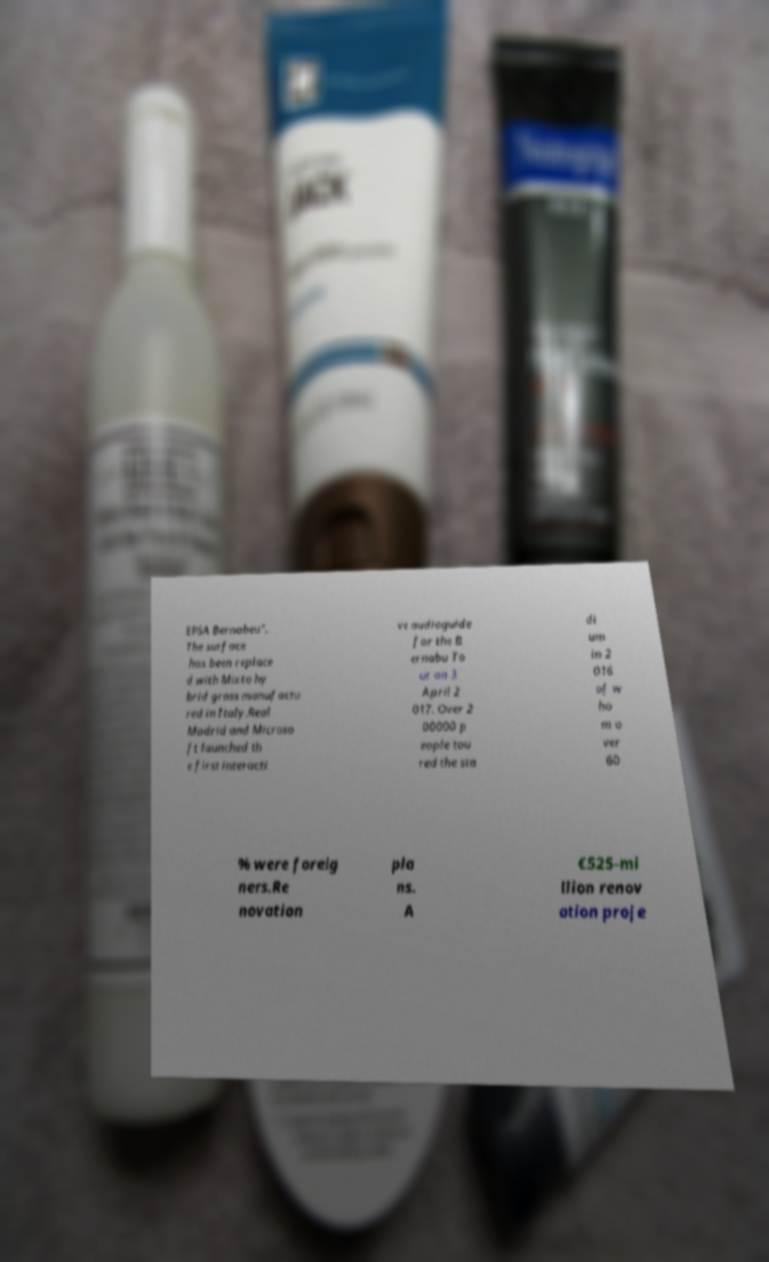There's text embedded in this image that I need extracted. Can you transcribe it verbatim? EPSA Bernabeu". The surface has been replace d with Mixto hy brid grass manufactu red in Italy.Real Madrid and Microso ft launched th e first interacti ve audioguide for the B ernabu To ur on 3 April 2 017. Over 2 00000 p eople tou red the sta di um in 2 016 of w ho m o ver 60 % were foreig ners.Re novation pla ns. A €525-mi llion renov ation proje 